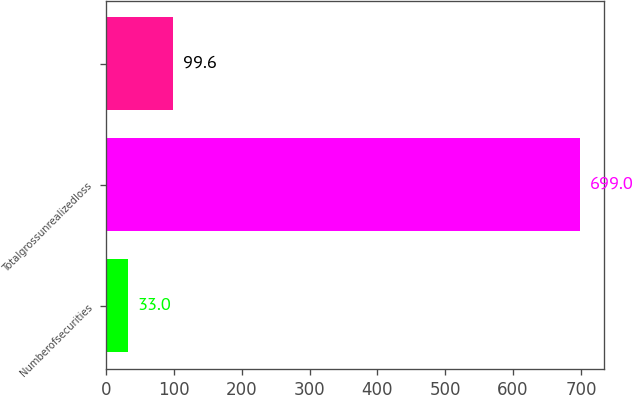Convert chart to OTSL. <chart><loc_0><loc_0><loc_500><loc_500><bar_chart><fcel>Numberofsecurities<fcel>Totalgrossunrealizedloss<fcel>Unnamed: 2<nl><fcel>33<fcel>699<fcel>99.6<nl></chart> 